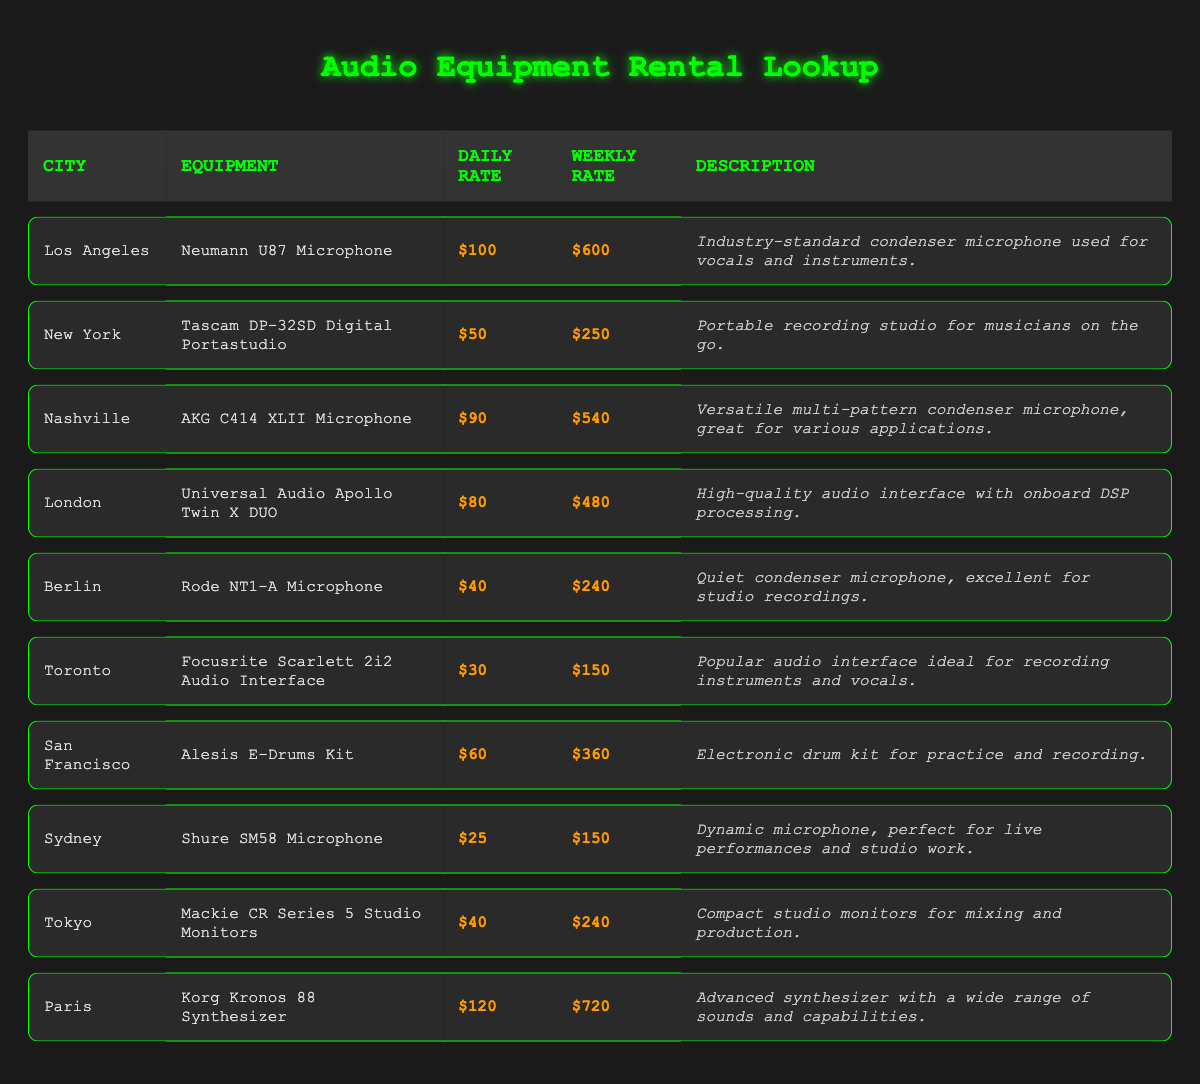What is the rental price per day for the Neumann U87 Microphone in Los Angeles? The table shows that the rental price per day for the Neumann U87 Microphone in Los Angeles is listed under the corresponding columns. Looking at the "Daily Rate" for that entry, the price is $100.
Answer: $100 Which equipment can be rented for the lowest weekly rate? By inspecting the "Weekly Rate" column across all entries, the lowest rate is $150, which can be verified from the rows for both the Focusrite Scarlett 2i2 Audio Interface (in Toronto) and the Shure SM58 Microphone (in Sydney).
Answer: Focusrite Scarlett 2i2 Audio Interface, Shure SM58 Microphone Is the rental price for the Korg Kronos 88 Synthesizer in Paris higher than the average daily rental price of all other equipment? First, we calculate the average daily rental price by summing all the daily rates: $100 + $50 + $90 + $80 + $40 + $30 + $60 + $25 + $40 + $120 = $735. There are 10 pieces of equipment, so the average is $735/10 = $73.5. The Korg Kronos 88 Synthesizer's daily rate is $120, which is higher than the average of $73.5.
Answer: Yes What is the difference in weekly rental price between the AKG C414 XLII Microphone in Nashville and the Shure SM58 Microphone in Sydney? The weekly rental price for the AKG C414 XLII Microphone is $540, and for the Shure SM58 Microphone it is $150. We subtract the lower price from the higher price: $540 - $150 = $390.
Answer: $390 Which city has the second-highest daily rental price for equipment? First, we need to compile a list of the daily rates from highest to lowest: Paris ($120), Los Angeles ($100), Nashville ($90), New York ($50), London ($80), San Francisco ($60), Tokyo ($40), Berlin ($40), Toronto ($30), Sydney ($25). The city with the second-highest daily rate is Los Angeles.
Answer: Los Angeles Are all microphones listed in the table priced under $100 per day? By evaluating each microphone’s daily rental price, the Neumann U87 ($100), AKG C414 ($90), Rode NT1-A ($40), Shure SM58 ($25) show that not all microphones are under $100. The Neumann U87 is precisely $100, thus confirming that the statement is false.
Answer: No What is the total weekly rental price for all the equipment listed in Berlin? The only equipment listed in Berlin is the Rode NT1-A Microphone, which has a weekly rental price of $240. So, the total weekly rental price is simply $240 since it’s the only entry.
Answer: $240 How much more does it cost to rent the digital portastudio in New York per week compared to renting the audio interface in Toronto? The weekly rental price for the Tascam DP-32SD Digital Portastudio in New York is $250, while for the Focusrite Scarlett 2i2 Audio Interface in Toronto, it is $150. We calculate the difference: $250 - $150 = $100.
Answer: $100 